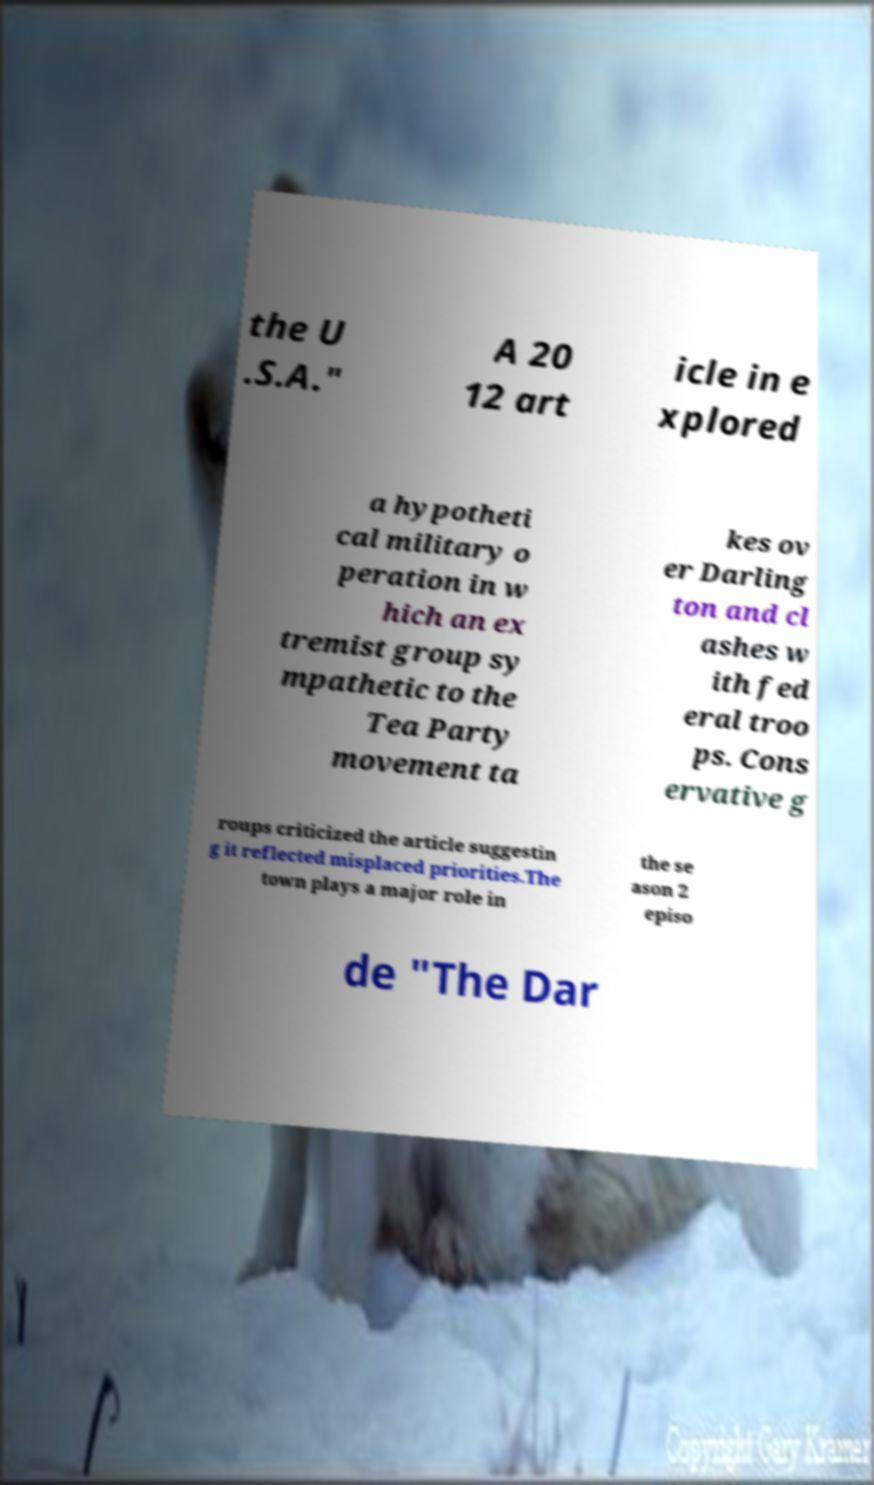Could you assist in decoding the text presented in this image and type it out clearly? the U .S.A." A 20 12 art icle in e xplored a hypotheti cal military o peration in w hich an ex tremist group sy mpathetic to the Tea Party movement ta kes ov er Darling ton and cl ashes w ith fed eral troo ps. Cons ervative g roups criticized the article suggestin g it reflected misplaced priorities.The town plays a major role in the se ason 2 episo de "The Dar 